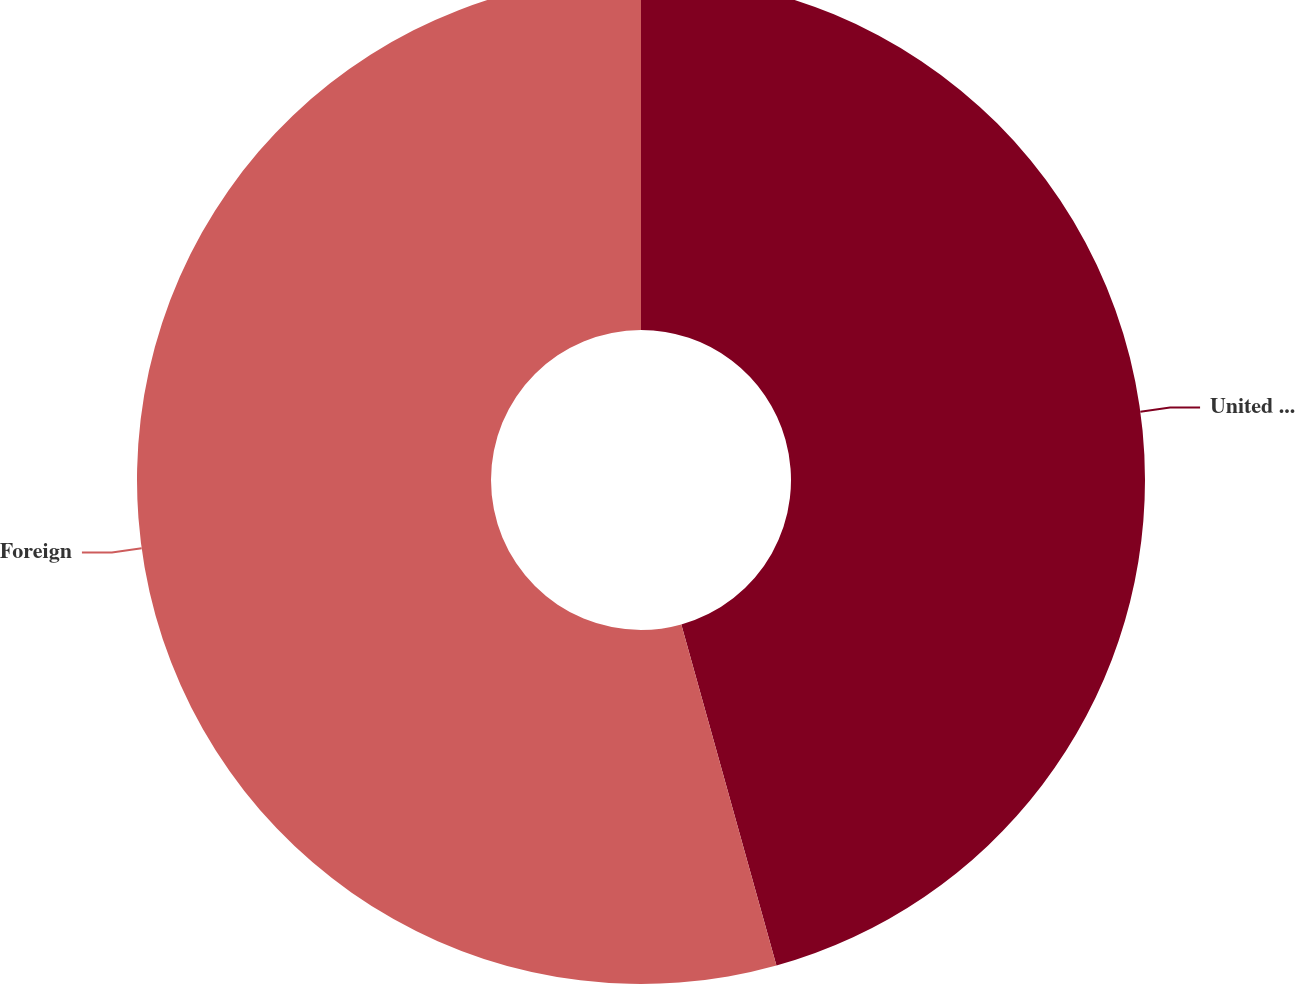Convert chart to OTSL. <chart><loc_0><loc_0><loc_500><loc_500><pie_chart><fcel>United States<fcel>Foreign<nl><fcel>45.67%<fcel>54.33%<nl></chart> 